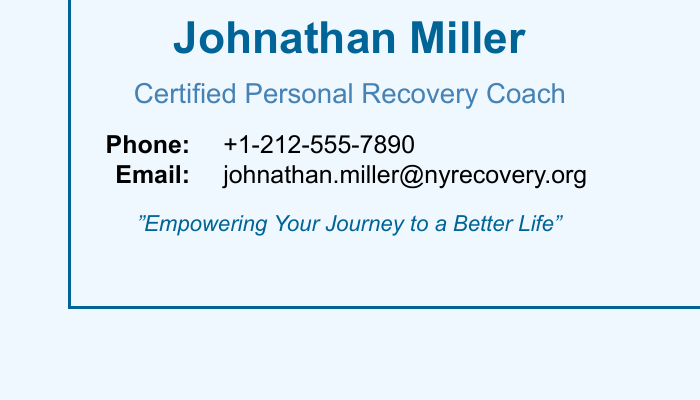What is the name on the business card? The name displayed prominently on the business card is Johnathan Miller.
Answer: Johnathan Miller What is the title of the personal recovery coach? The title on the business card indicates the profession of the individual, which is Certified Personal Recovery Coach.
Answer: Certified Personal Recovery Coach What is the phone number provided? The phone number is specifically listed in a format that includes the country code, which is +1-212-555-7890.
Answer: +1-212-555-7890 What is the email address given? The email address is presented clearly on the card, which is johnathan.miller@nyrecovery.org.
Answer: johnathan.miller@nyrecovery.org What is the motivational tagline on the card? The business card features a motivational statement meant to inspire, which reads "Empowering Your Journey to a Better Life."
Answer: "Empowering Your Journey to a Better Life" How many contact methods are provided? The document includes two contact methods: a phone number and an email address.
Answer: Two What color is used for the primary text? The primary color used for the name is a shade described as primaryColor, which is RGB color value (0,100,150).
Answer: primaryColor What type of document is this? The structure and elements presented indicate that this is a business card.
Answer: Business card 